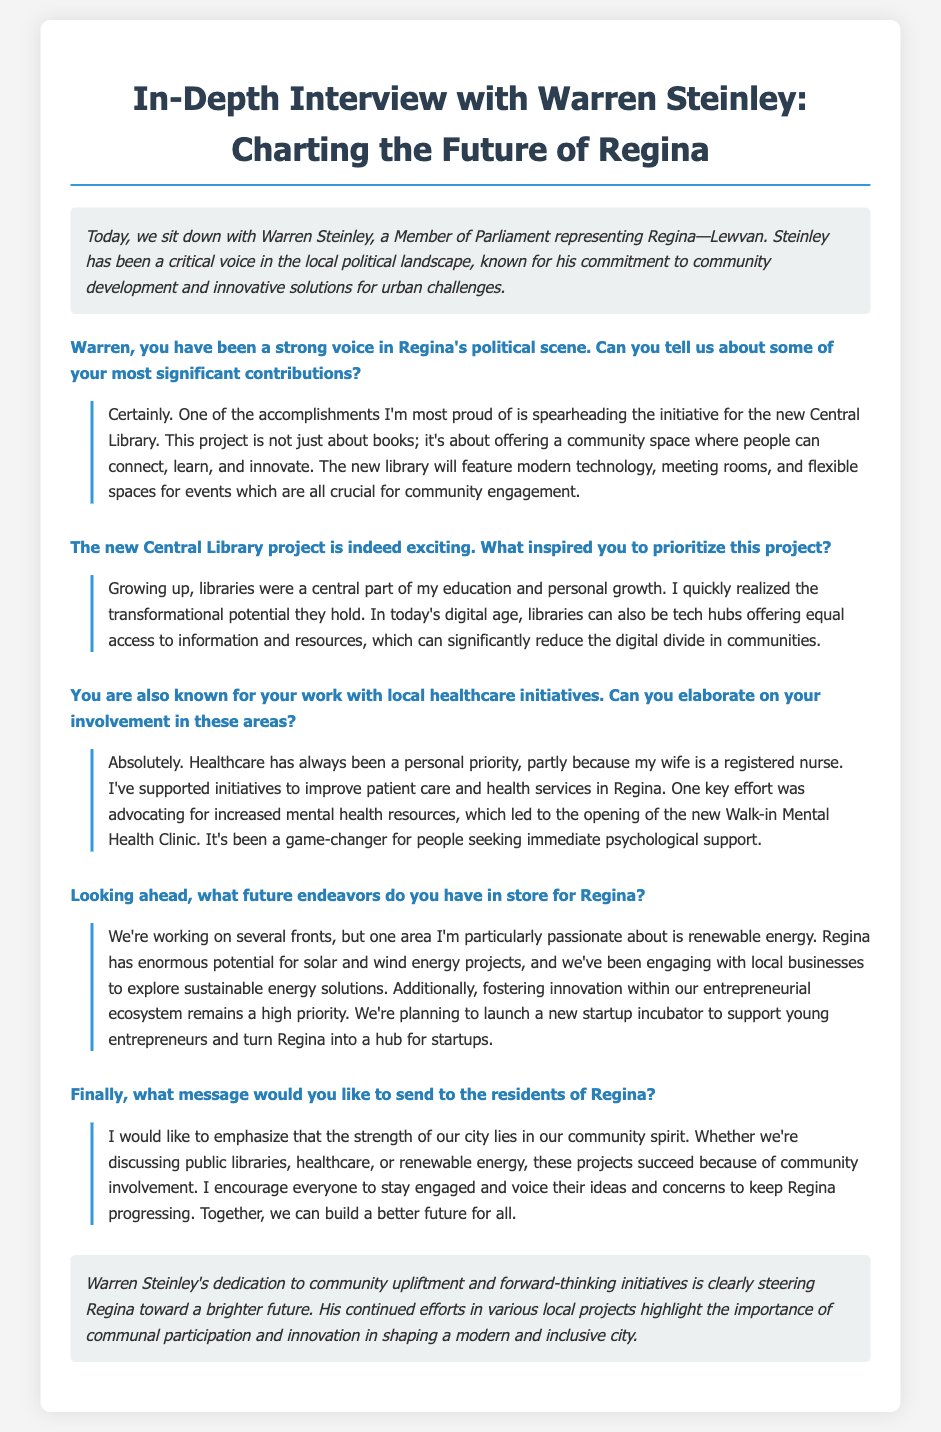What is the name of the MP interviewed? The document features an interview with Warren Steinley, who is a Member of Parliament.
Answer: Warren Steinley What is one of Steinley's significant contributions? The document mentions the initiative for the new Central Library as a key contribution.
Answer: New Central Library What was the purpose of the new Walk-in Mental Health Clinic? The document states that the clinic was established to provide immediate psychological support.
Answer: Immediate psychological support What area is Steinley passionate about for future projects? The document indicates that renewable energy is a key focus for Steinley's future endeavors.
Answer: Renewable energy What role did libraries play in Steinley's personal development? The document mentions that libraries were central to his education and personal growth.
Answer: Central to education What does Steinley encourage residents to do? The document states that he encourages community involvement and voicing ideas.
Answer: Stay engaged What kind of incubator is planned for young entrepreneurs? The document specifies that a startup incubator is in the works to support young entrepreneurs.
Answer: Startup incubator How does Steinley view the strength of Regina? The document indicates he believes the strength of the city lies in community spirit.
Answer: Community spirit What is the aim of the new library according to Steinley? The document describes the library as a community space for connection, learning, and innovation.
Answer: Community space for connection, learning, and innovation 